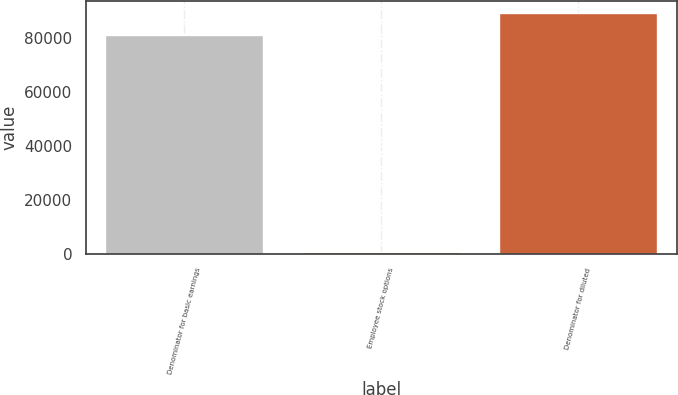Convert chart to OTSL. <chart><loc_0><loc_0><loc_500><loc_500><bar_chart><fcel>Denominator for basic earnings<fcel>Employee stock options<fcel>Denominator for diluted<nl><fcel>80974<fcel>735<fcel>89071.4<nl></chart> 